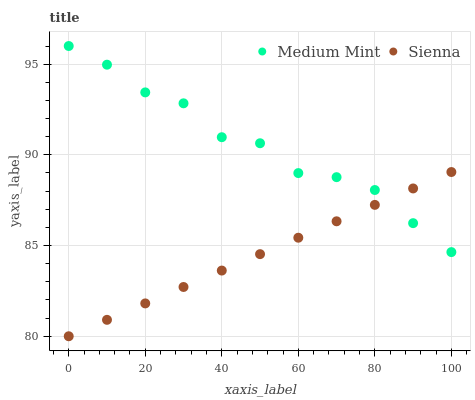Does Sienna have the minimum area under the curve?
Answer yes or no. Yes. Does Medium Mint have the maximum area under the curve?
Answer yes or no. Yes. Does Sienna have the maximum area under the curve?
Answer yes or no. No. Is Sienna the smoothest?
Answer yes or no. Yes. Is Medium Mint the roughest?
Answer yes or no. Yes. Is Sienna the roughest?
Answer yes or no. No. Does Sienna have the lowest value?
Answer yes or no. Yes. Does Medium Mint have the highest value?
Answer yes or no. Yes. Does Sienna have the highest value?
Answer yes or no. No. Does Medium Mint intersect Sienna?
Answer yes or no. Yes. Is Medium Mint less than Sienna?
Answer yes or no. No. Is Medium Mint greater than Sienna?
Answer yes or no. No. 